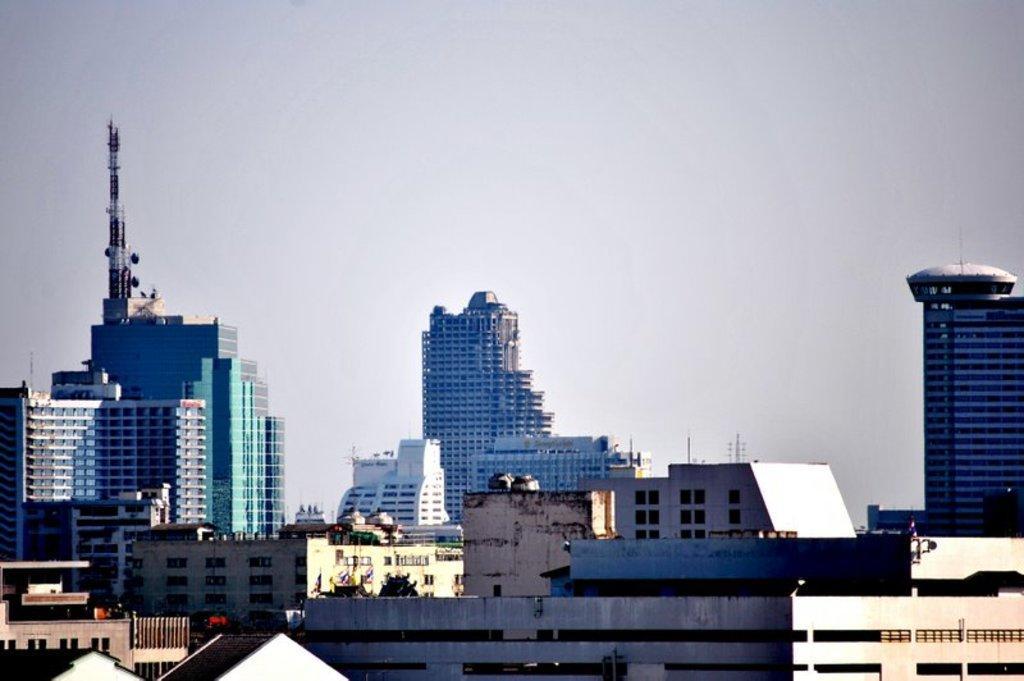Could you give a brief overview of what you see in this image? In this picture I can see there are few buildings and there are glass windows and doors and the sky is clear. 